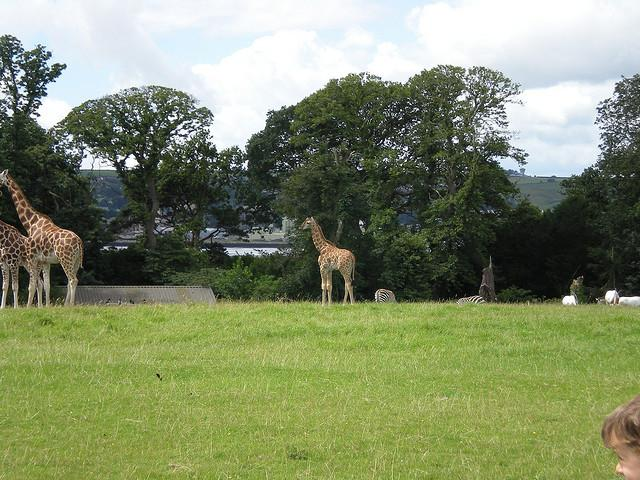What are the zebras doing?

Choices:
A) feeding
B) bathing
C) attacking giraffes
D) grooming feeding 